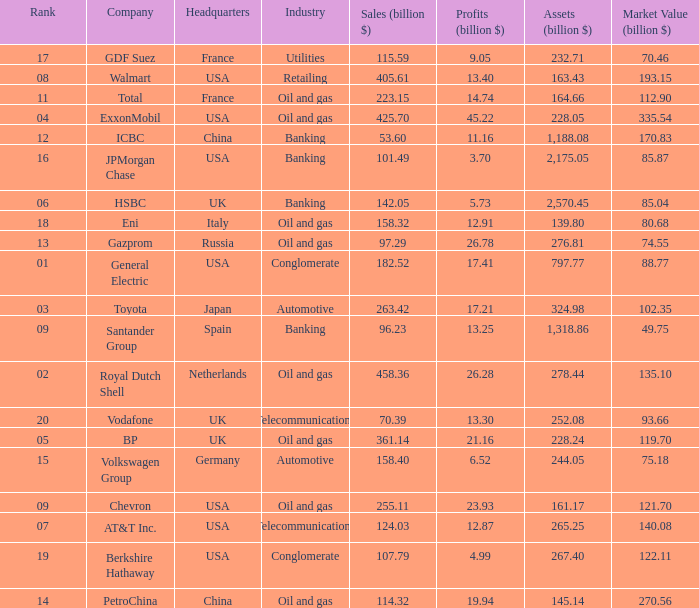How many Assets (billion $) has an Industry of oil and gas, and a Rank of 9, and a Market Value (billion $) larger than 121.7? None. 